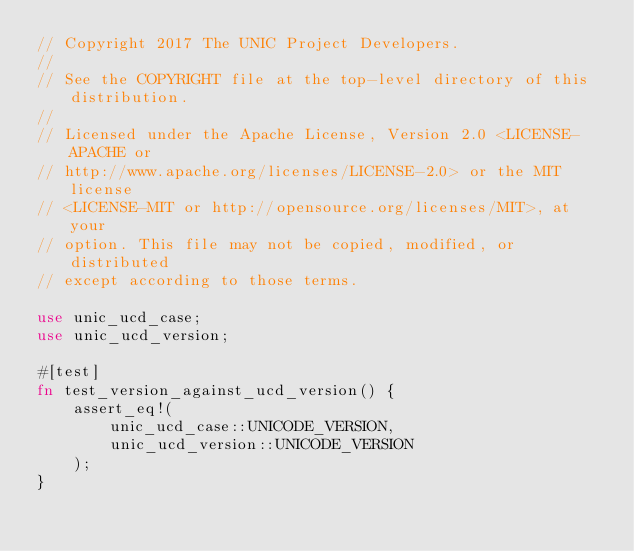<code> <loc_0><loc_0><loc_500><loc_500><_Rust_>// Copyright 2017 The UNIC Project Developers.
//
// See the COPYRIGHT file at the top-level directory of this distribution.
//
// Licensed under the Apache License, Version 2.0 <LICENSE-APACHE or
// http://www.apache.org/licenses/LICENSE-2.0> or the MIT license
// <LICENSE-MIT or http://opensource.org/licenses/MIT>, at your
// option. This file may not be copied, modified, or distributed
// except according to those terms.

use unic_ucd_case;
use unic_ucd_version;

#[test]
fn test_version_against_ucd_version() {
    assert_eq!(
        unic_ucd_case::UNICODE_VERSION,
        unic_ucd_version::UNICODE_VERSION
    );
}
</code> 